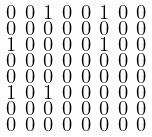Convert formula to latex. <formula><loc_0><loc_0><loc_500><loc_500>\begin{smallmatrix} 0 & 0 & 1 & 0 & 0 & 1 & 0 & 0 \\ 0 & 0 & 0 & 0 & 0 & 0 & 0 & 0 \\ 1 & 0 & 0 & 0 & 0 & 1 & 0 & 0 \\ 0 & 0 & 0 & 0 & 0 & 0 & 0 & 0 \\ 0 & 0 & 0 & 0 & 0 & 0 & 0 & 0 \\ 1 & 0 & 1 & 0 & 0 & 0 & 0 & 0 \\ 0 & 0 & 0 & 0 & 0 & 0 & 0 & 0 \\ 0 & 0 & 0 & 0 & 0 & 0 & 0 & 0 \end{smallmatrix}</formula> 